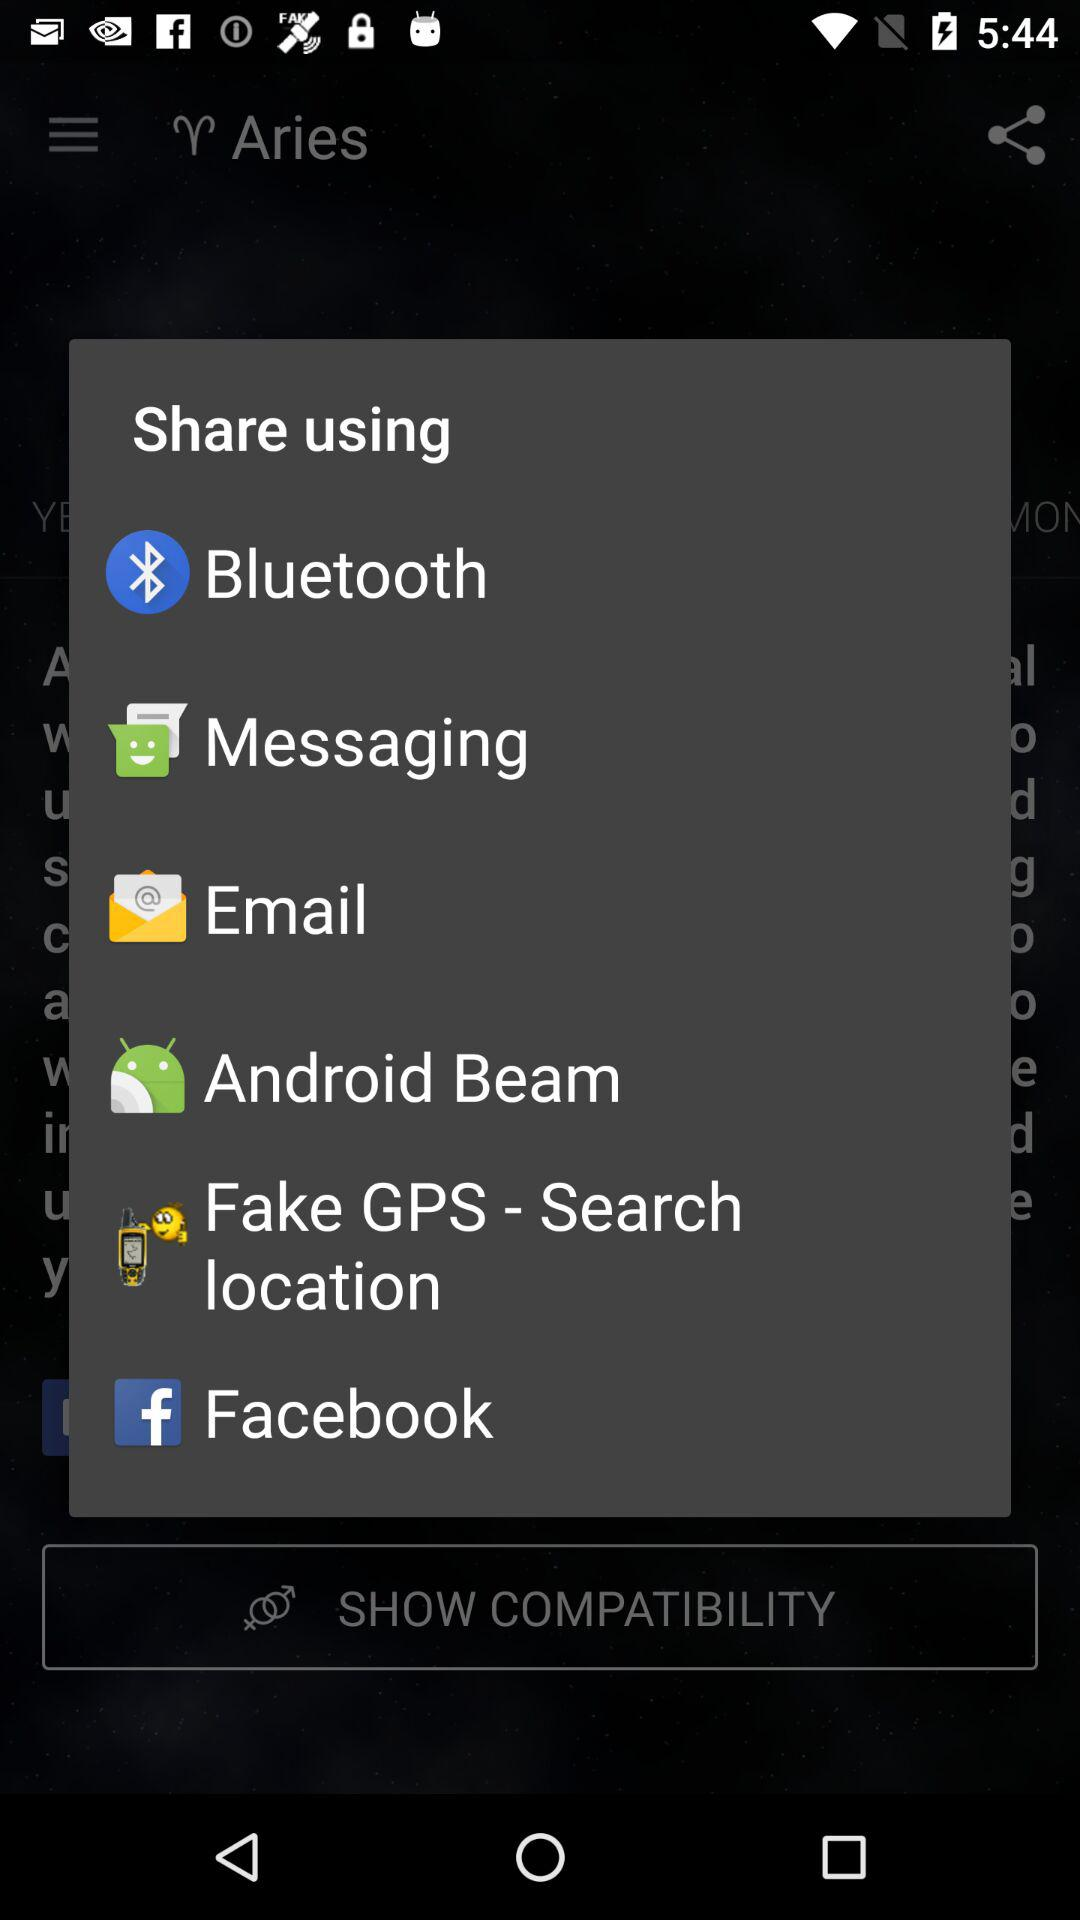What applications are used to share the content? The applications that can be used to share are "Bluetooth", "Messaging", "Email", "Android Beam", "Fake GPS - Search location" and "Facebook". 